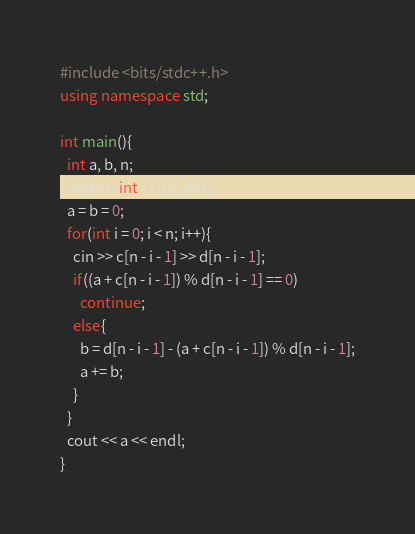<code> <loc_0><loc_0><loc_500><loc_500><_C++_>#include <bits/stdc++.h>
using namespace std;

int main(){
  int a, b, n;
  vector<int> c(n), d(n);
  a = b = 0;
  for(int i = 0; i < n; i++){
    cin >> c[n - i - 1] >> d[n - i - 1];
    if((a + c[n - i - 1]) % d[n - i - 1] == 0)
      continue;
    else{
      b = d[n - i - 1] - (a + c[n - i - 1]) % d[n - i - 1];
      a += b;
    }
  }
  cout << a << endl;
}</code> 